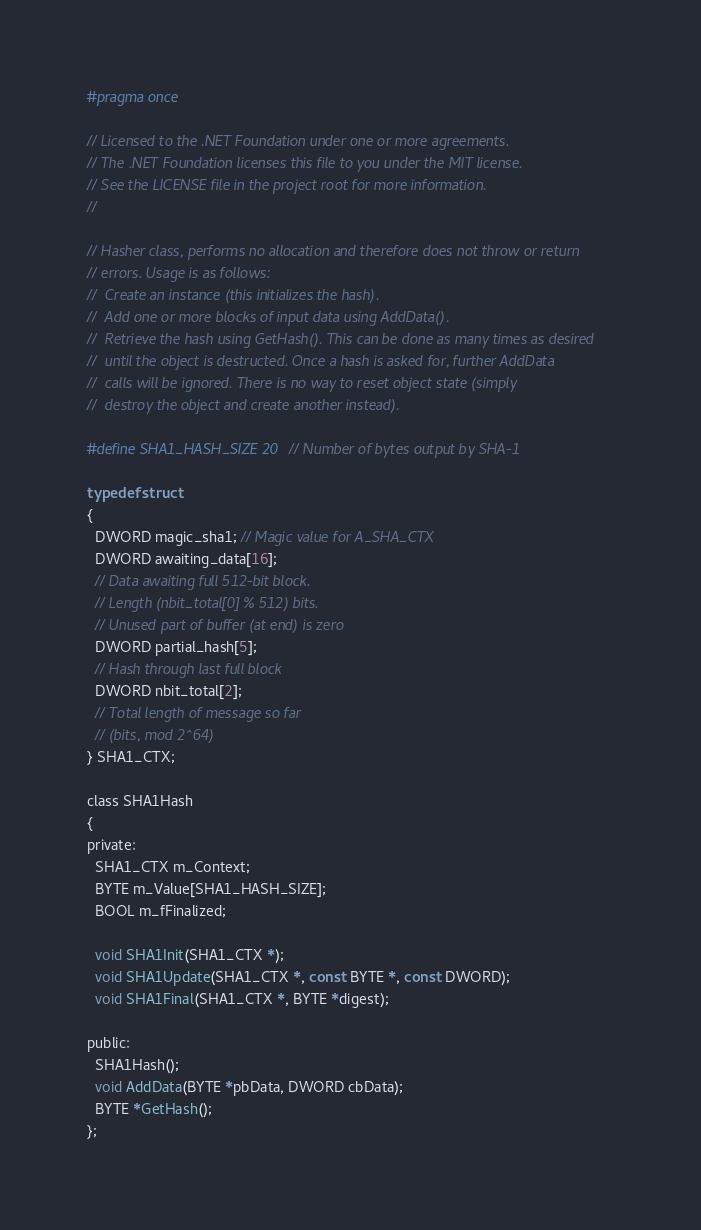<code> <loc_0><loc_0><loc_500><loc_500><_C_>#pragma once

// Licensed to the .NET Foundation under one or more agreements.
// The .NET Foundation licenses this file to you under the MIT license.
// See the LICENSE file in the project root for more information.
//

// Hasher class, performs no allocation and therefore does not throw or return
// errors. Usage is as follows:
//  Create an instance (this initializes the hash).
//  Add one or more blocks of input data using AddData().
//  Retrieve the hash using GetHash(). This can be done as many times as desired
//  until the object is destructed. Once a hash is asked for, further AddData
//  calls will be ignored. There is no way to reset object state (simply
//  destroy the object and create another instead).

#define SHA1_HASH_SIZE 20 // Number of bytes output by SHA-1

typedef struct
{
  DWORD magic_sha1; // Magic value for A_SHA_CTX
  DWORD awaiting_data[16];
  // Data awaiting full 512-bit block.
  // Length (nbit_total[0] % 512) bits.
  // Unused part of buffer (at end) is zero
  DWORD partial_hash[5];
  // Hash through last full block
  DWORD nbit_total[2];
  // Total length of message so far
  // (bits, mod 2^64)
} SHA1_CTX;

class SHA1Hash
{
private:
  SHA1_CTX m_Context;
  BYTE m_Value[SHA1_HASH_SIZE];
  BOOL m_fFinalized;

  void SHA1Init(SHA1_CTX *);
  void SHA1Update(SHA1_CTX *, const BYTE *, const DWORD);
  void SHA1Final(SHA1_CTX *, BYTE *digest);

public:
  SHA1Hash();
  void AddData(BYTE *pbData, DWORD cbData);
  BYTE *GetHash();
};
</code> 